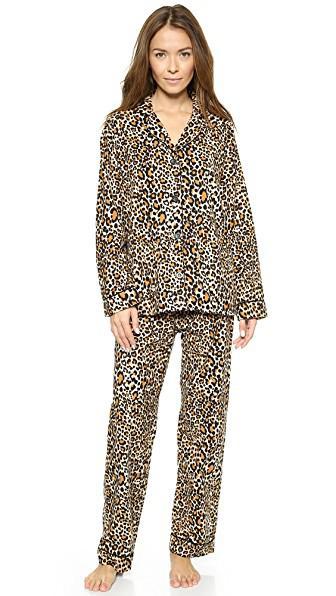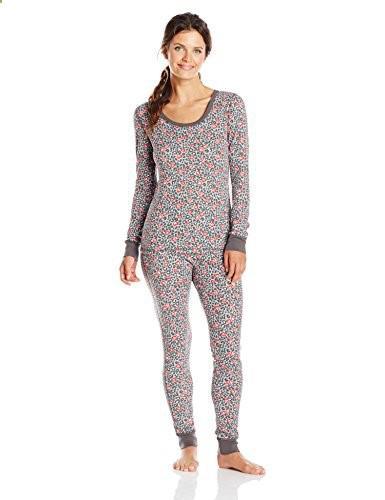The first image is the image on the left, the second image is the image on the right. For the images displayed, is the sentence "The female in the right image is standing with her feet crossed." factually correct? Answer yes or no. No. The first image is the image on the left, the second image is the image on the right. Evaluate the accuracy of this statement regarding the images: "There is one woman wearing tight fitting pajamas, and one woman wearing more loose fitting pajamas.". Is it true? Answer yes or no. Yes. 